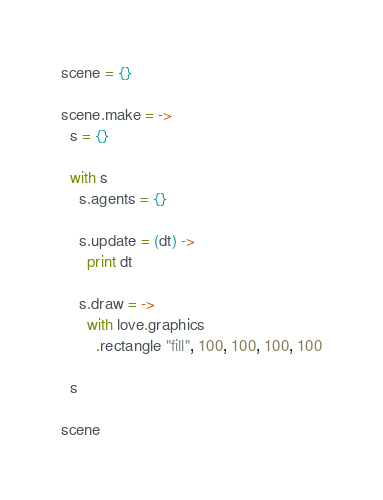<code> <loc_0><loc_0><loc_500><loc_500><_MoonScript_>scene = {}

scene.make = ->
  s = {}

  with s
    s.agents = {}
    
    s.update = (dt) ->
      print dt
      
    s.draw = ->
      with love.graphics
        .rectangle "fill", 100, 100, 100, 100
  
  s

scene
</code> 